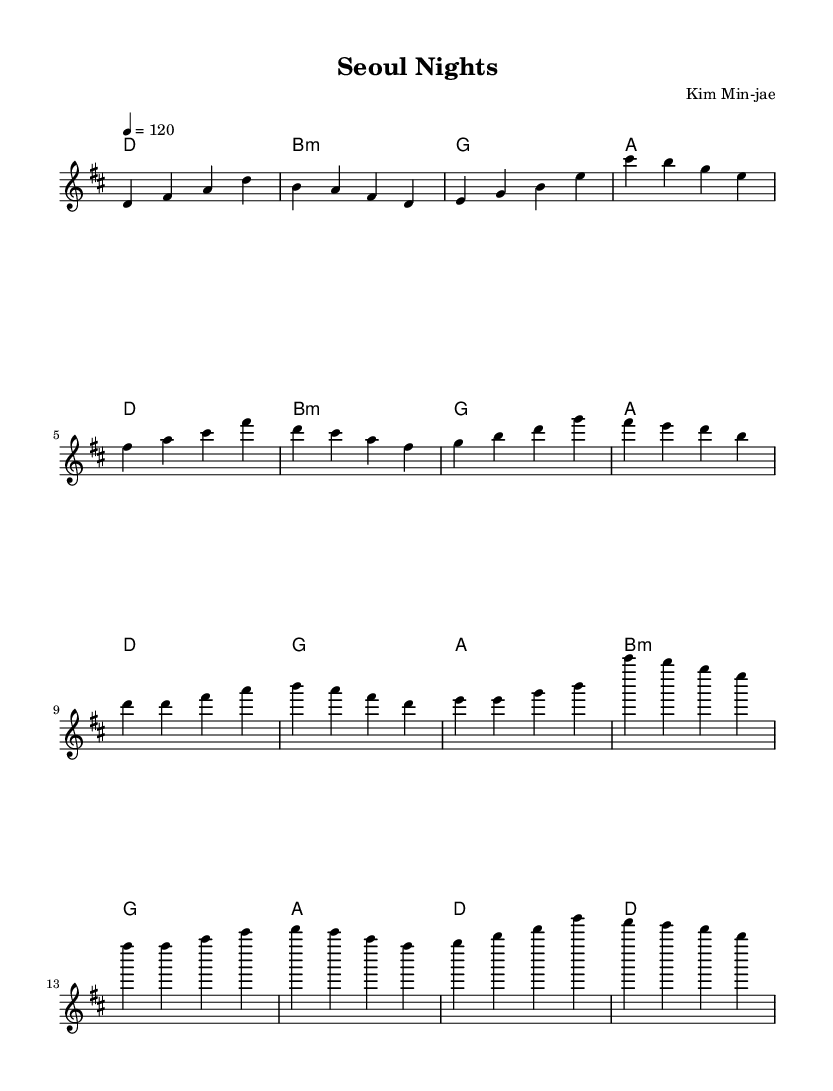What is the key signature of this music? The key signature is indicated at the beginning of the score. Here, it shows one sharp, which corresponds to D major.
Answer: D major What is the time signature of this music? The time signature is displayed after the key signature and is indicated by the numbers above the staff. In this case, it is four beats per measure, or 4/4 time.
Answer: 4/4 What is the tempo marking for this score? The tempo marking is found at the beginning of the score, represented as "4 = 120". This indicates that the quarter note is set to 120 beats per minute.
Answer: 120 How many measures are in the verse section? To find the number of measures, we count the segments of music in the verse section on the score. There are 8 measures total in the verse part.
Answer: 8 What is the first chord in the chorus? The first chord in the chorus can be found by looking at the chord progression written beneath the melody. The first chord indicated for the chorus is D major.
Answer: D What lyrical theme is depicted in the chorus? By examining the lyrics written under the melody for the chorus, it describes a night in Seoul and dreams, reflecting positive cultural connections.
Answer: Night and Dreams What is the overall form of the song? The overall form can be inferred by looking at the structure of the music sections. The piece follows a "Verse - Chorus - Verse - Chorus" format, alternating between these two sections.
Answer: Verse - Chorus 